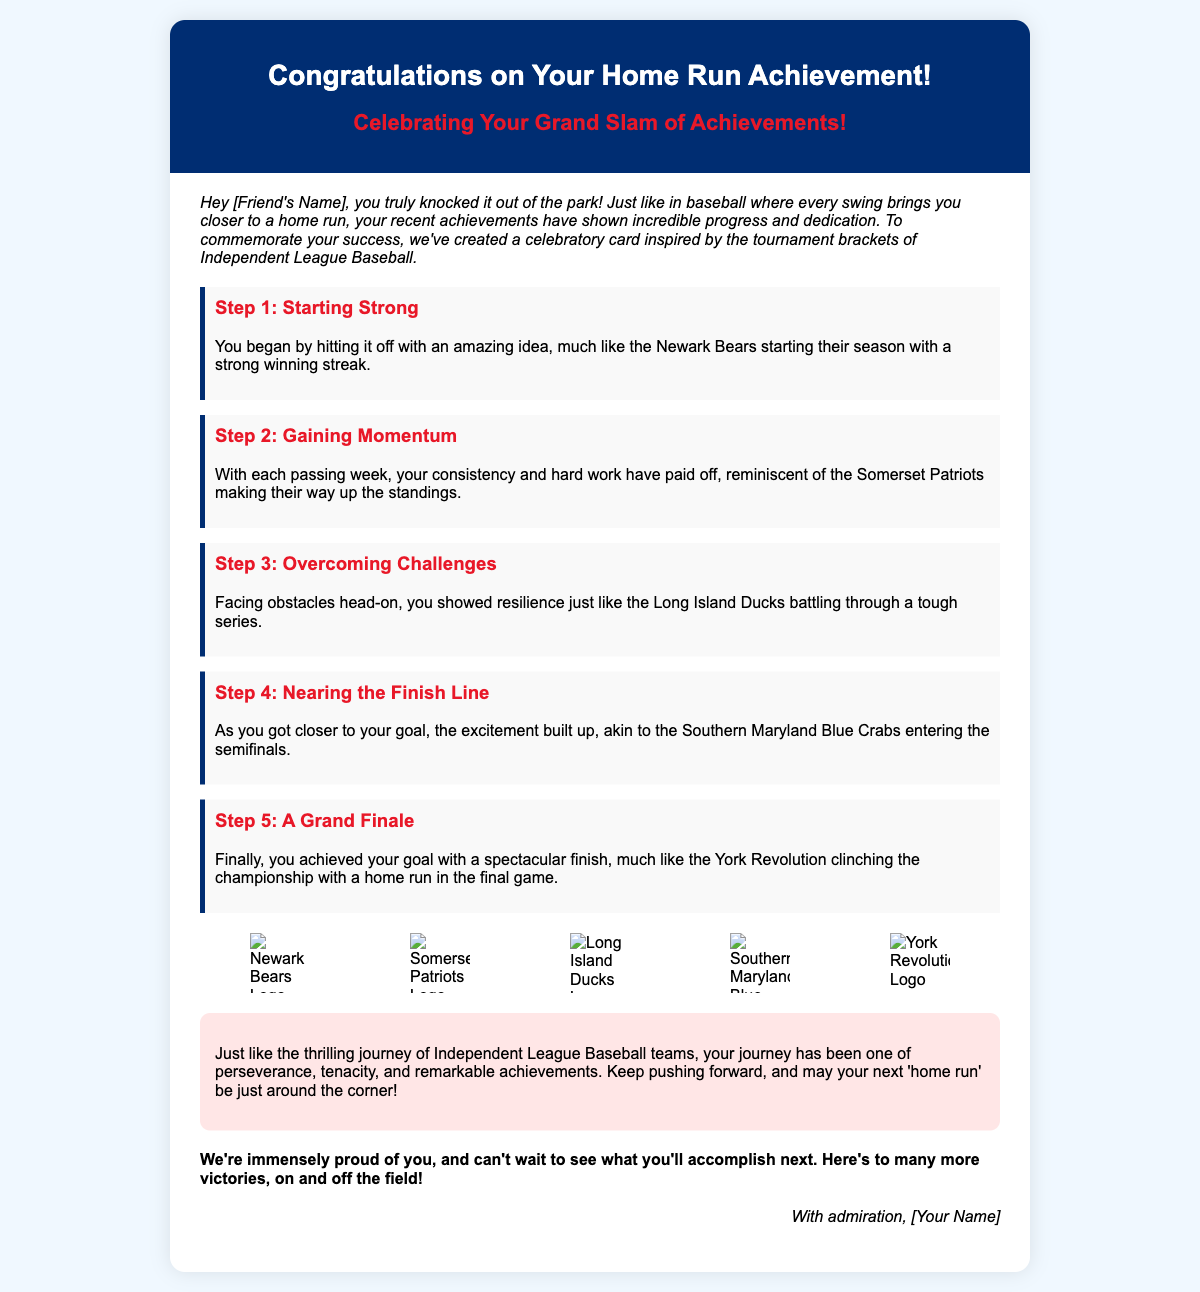What is the title of the card? The title found prominently at the top of the card is "Congratulations on Your Home Run Achievement!"
Answer: Congratulations on Your Home Run Achievement! Who is the card addressed to? The card is personalized for "Friend's Name," indicating it is meant for a specific individual.
Answer: [Friend's Name] How many steps are mentioned in the achievement progression? The document outlines a progression of achievements broken down into five distinct steps.
Answer: 5 What is the color of the card's header? The header has a background color of a deep blue, represented by the hex color code #002d72.
Answer: #002d72 Which team is mentioned in the final achievement step? The last milestone refers to the York Revolution, contextualized in the success of clinching a championship.
Answer: York Revolution What type of imagery is featured in the card? The card includes logos from various Independent League Baseball teams as part of the celebratory imagery.
Answer: Logos What is the overall theme of the card? The card is themed around celebrating achievements in a manner similar to the excitement and progression in baseball tournaments.
Answer: Baseball achievements What is the concluding sentiment expressed in the card? The card concludes with an encouraging note expressing pride and anticipation for future achievements.
Answer: Proud of you What style of card is this document representing? The document represents a greeting card, specifically a congratulatory card.
Answer: Greeting card 